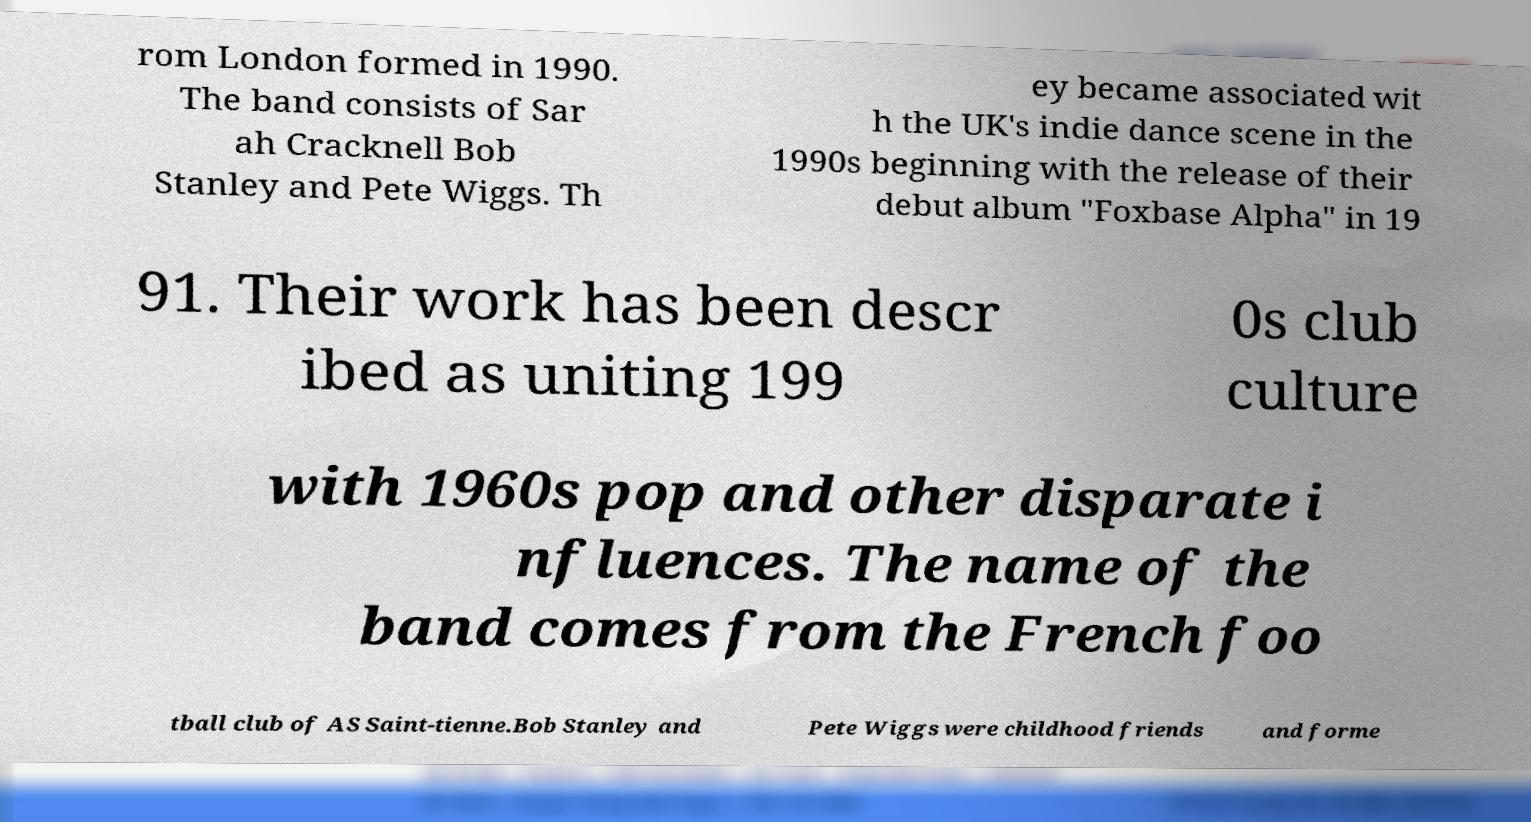Please identify and transcribe the text found in this image. rom London formed in 1990. The band consists of Sar ah Cracknell Bob Stanley and Pete Wiggs. Th ey became associated wit h the UK's indie dance scene in the 1990s beginning with the release of their debut album "Foxbase Alpha" in 19 91. Their work has been descr ibed as uniting 199 0s club culture with 1960s pop and other disparate i nfluences. The name of the band comes from the French foo tball club of AS Saint-tienne.Bob Stanley and Pete Wiggs were childhood friends and forme 